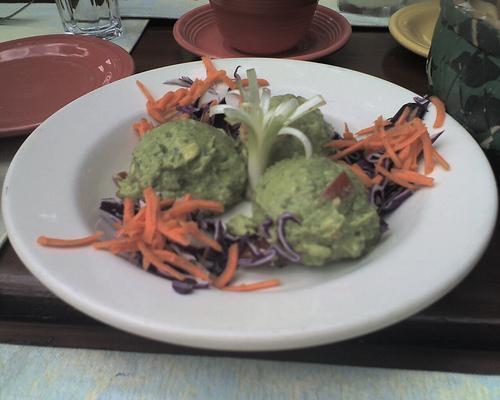How many red plates are shown?
Give a very brief answer. 2. How many yellow plates are shown?
Give a very brief answer. 1. 